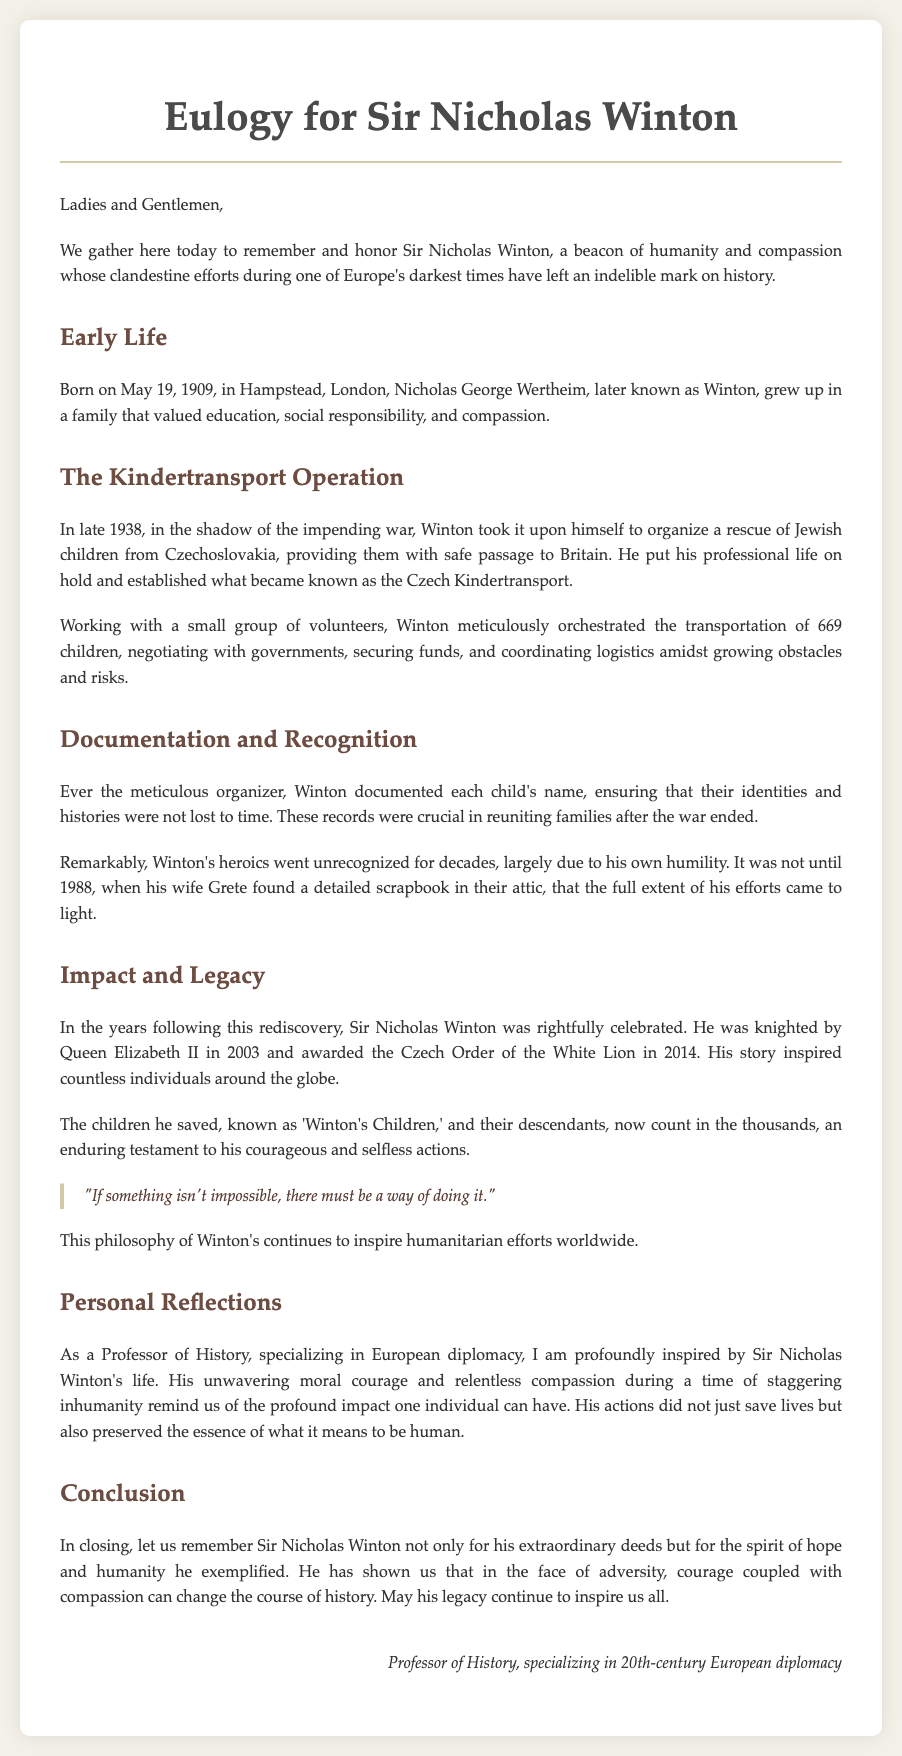What date was Sir Nicholas Winton born? The eulogy provides the specific date of Winton's birth, which is May 19, 1909.
Answer: May 19, 1909 How many children did Winton save through the Kindertransport? The document states that Winton organized the rescue of 669 children during the Kindertransport operation.
Answer: 669 What philosophy of Winton’s is quoted in the eulogy? The eulogy includes a quote from Winton that reflects his outlook on challenges, which is "If something isn't impossible, there must be a way of doing it."
Answer: "If something isn't impossible, there must be a way of doing it." Who discovered Winton's scrapbook that revealed his efforts? The document indicates that Winton's wife, Grete, found the detailed scrapbook in their attic.
Answer: Grete What honors did Winton receive later in life? The eulogy mentions that he was knighted by Queen Elizabeth II in 2003 and awarded the Czech Order of the White Lion in 2014.
Answer: Knighted by Queen Elizabeth II and awarded the Czech Order of the White Lion In what year did Winton's actions become publicly recognized? The eulogy states that Winton's heroics went unrecognized until 1988 when his wife found the scrapbook.
Answer: 1988 What is the significance of the term "Winton's Children"? This term refers to the children Winton saved, whose descendants now count in the thousands.
Answer: The children saved by Winton What personal reflection does the speaker express about Winton's impact? The speaker emphasizes Winton's unwavering moral courage and compassion as deeply inspiring and impactful.
Answer: Unwavering moral courage and compassion 